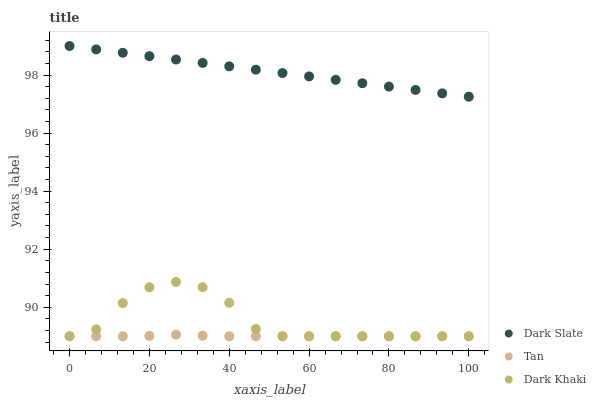Does Tan have the minimum area under the curve?
Answer yes or no. Yes. Does Dark Slate have the maximum area under the curve?
Answer yes or no. Yes. Does Dark Slate have the minimum area under the curve?
Answer yes or no. No. Does Tan have the maximum area under the curve?
Answer yes or no. No. Is Dark Slate the smoothest?
Answer yes or no. Yes. Is Dark Khaki the roughest?
Answer yes or no. Yes. Is Tan the smoothest?
Answer yes or no. No. Is Tan the roughest?
Answer yes or no. No. Does Dark Khaki have the lowest value?
Answer yes or no. Yes. Does Dark Slate have the lowest value?
Answer yes or no. No. Does Dark Slate have the highest value?
Answer yes or no. Yes. Does Tan have the highest value?
Answer yes or no. No. Is Dark Khaki less than Dark Slate?
Answer yes or no. Yes. Is Dark Slate greater than Tan?
Answer yes or no. Yes. Does Tan intersect Dark Khaki?
Answer yes or no. Yes. Is Tan less than Dark Khaki?
Answer yes or no. No. Is Tan greater than Dark Khaki?
Answer yes or no. No. Does Dark Khaki intersect Dark Slate?
Answer yes or no. No. 